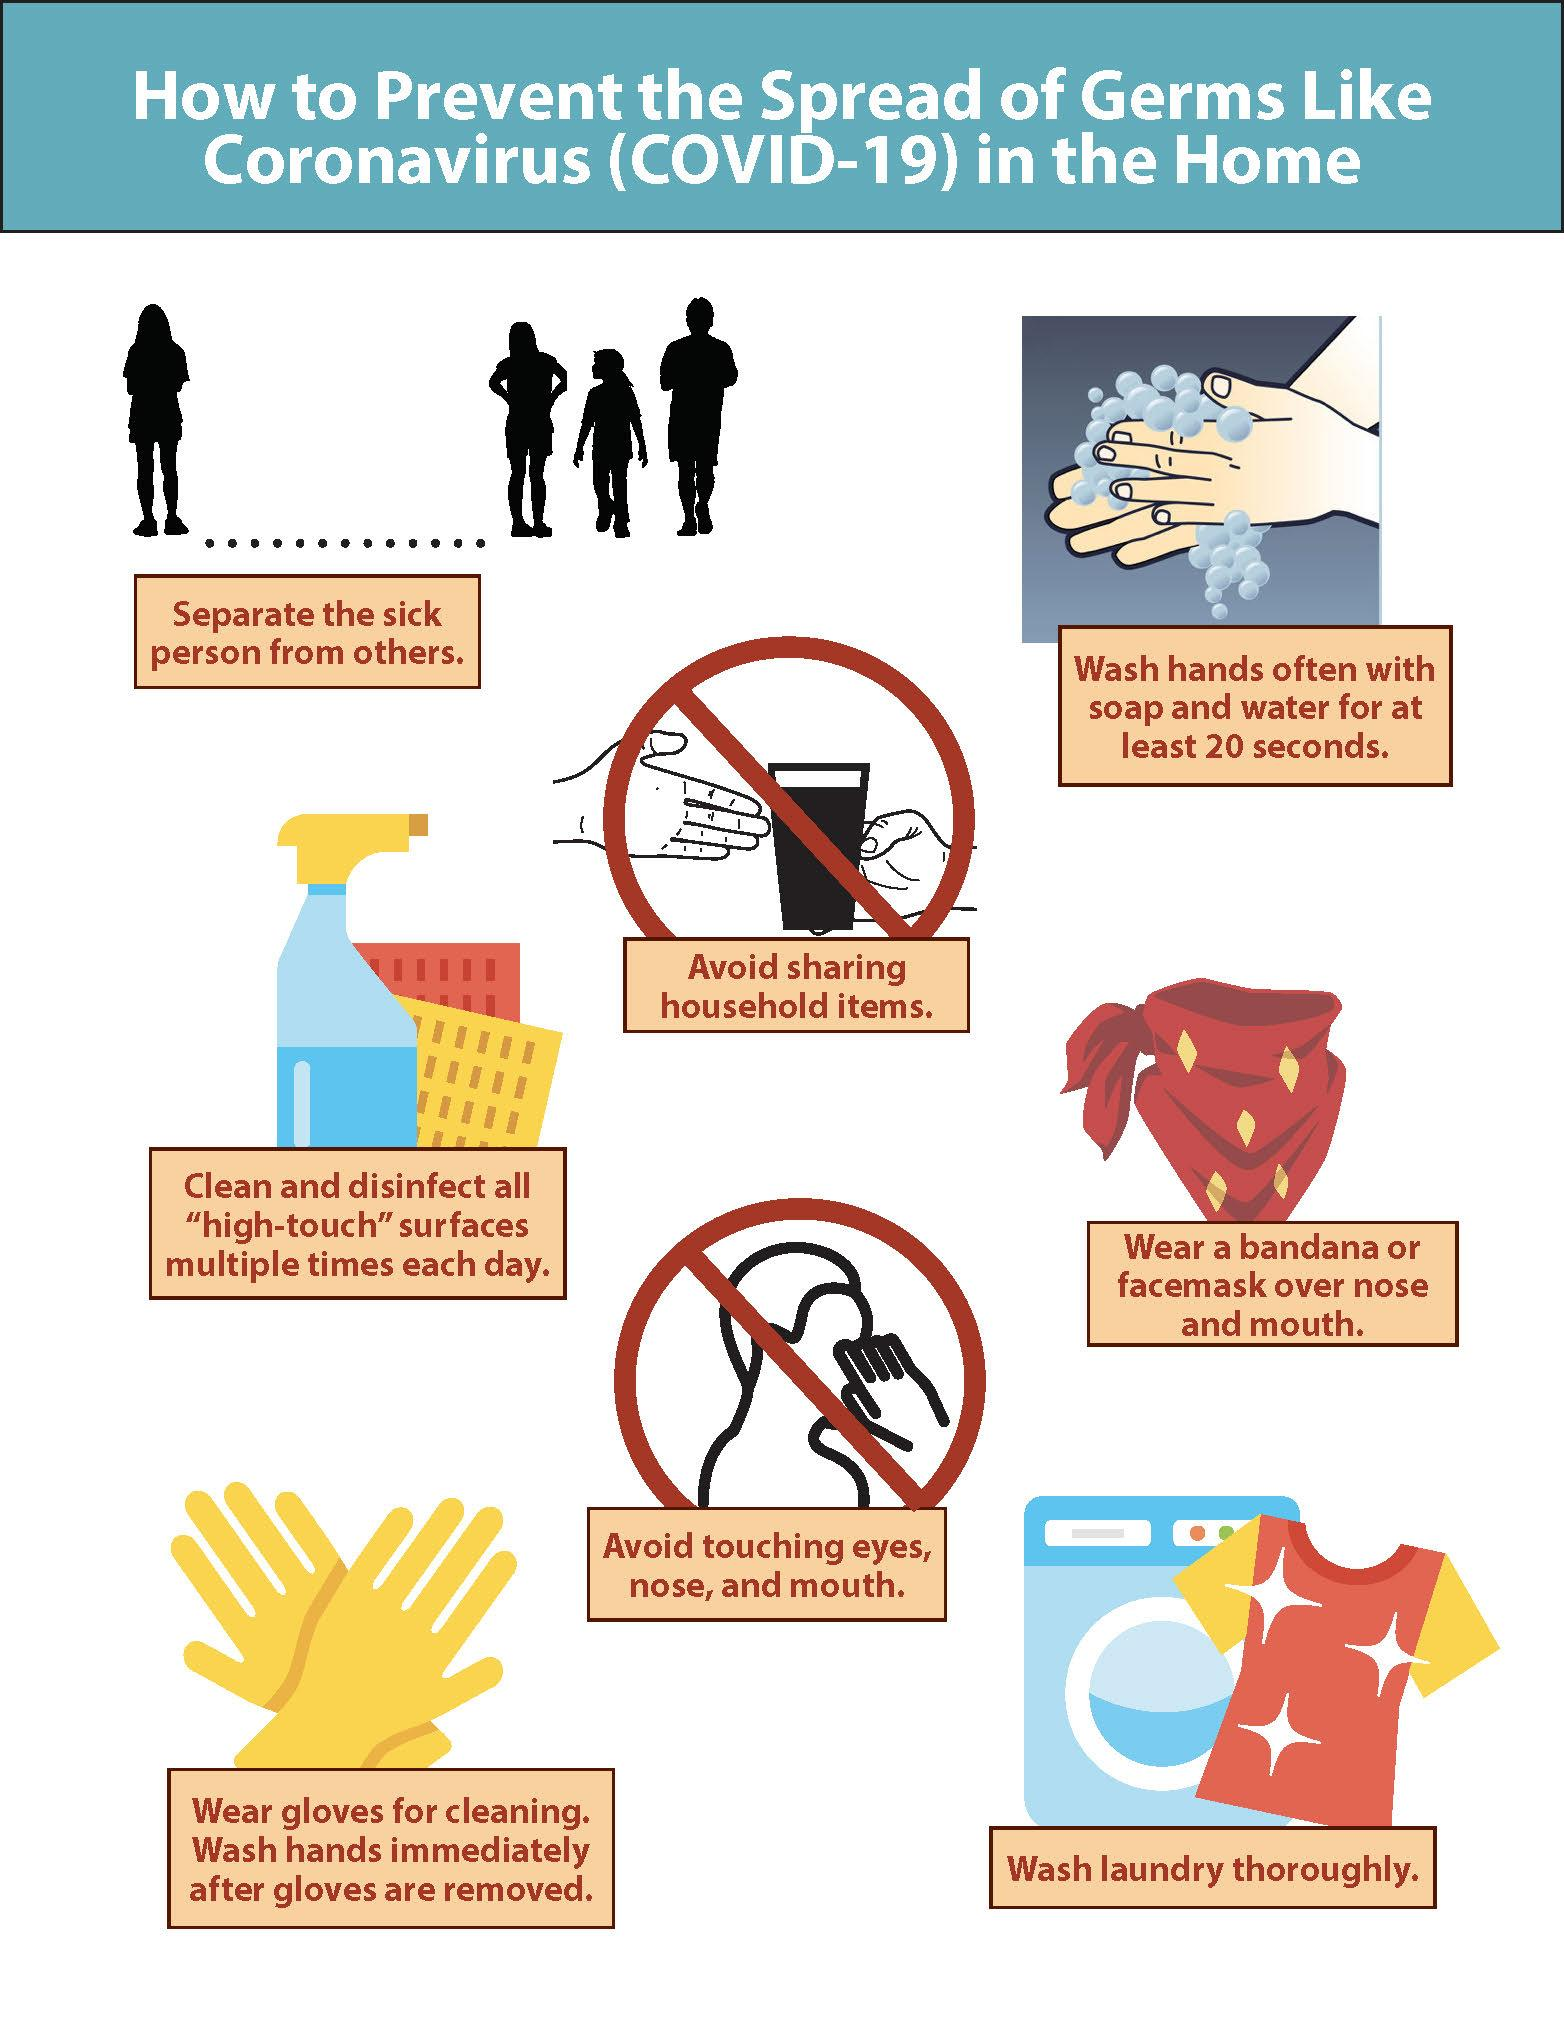Draw attention to some important aspects in this diagram. Two of the tips mention things to avoid. The infographic includes eight tips to prevent the spread of Coronavirus germs. 